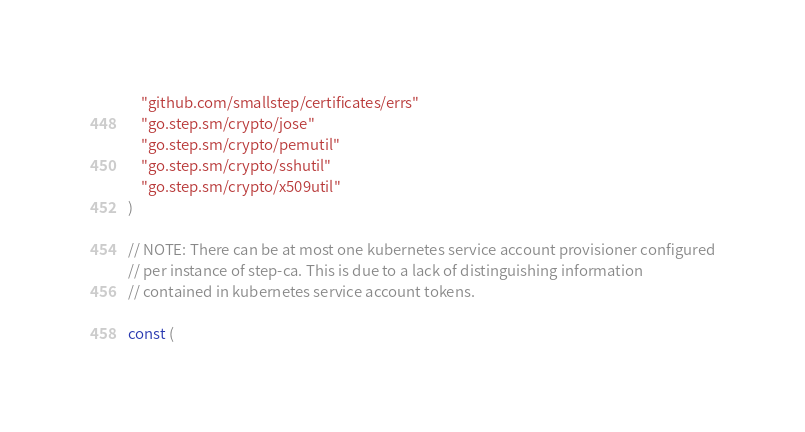<code> <loc_0><loc_0><loc_500><loc_500><_Go_>	"github.com/smallstep/certificates/errs"
	"go.step.sm/crypto/jose"
	"go.step.sm/crypto/pemutil"
	"go.step.sm/crypto/sshutil"
	"go.step.sm/crypto/x509util"
)

// NOTE: There can be at most one kubernetes service account provisioner configured
// per instance of step-ca. This is due to a lack of distinguishing information
// contained in kubernetes service account tokens.

const (</code> 